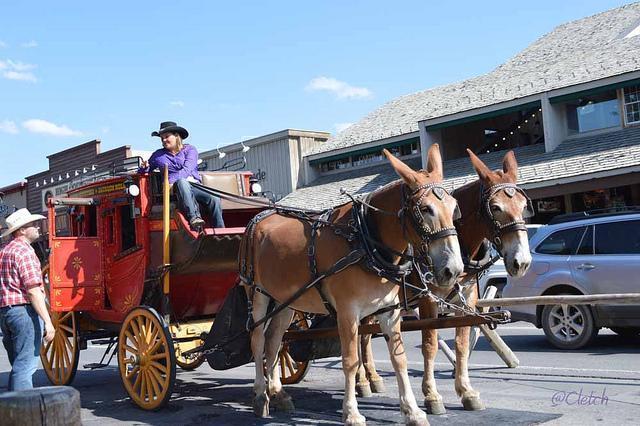What do both of the people have on their heads?
Select the accurate answer and provide explanation: 'Answer: answer
Rationale: rationale.'
Options: Cowboy hats, glasses, gas masks, helmets. Answer: cowboy hats.
Rationale: The two men that are visible are wearing cowboy-style hats on their heads and that is the only type of headwear seen. 